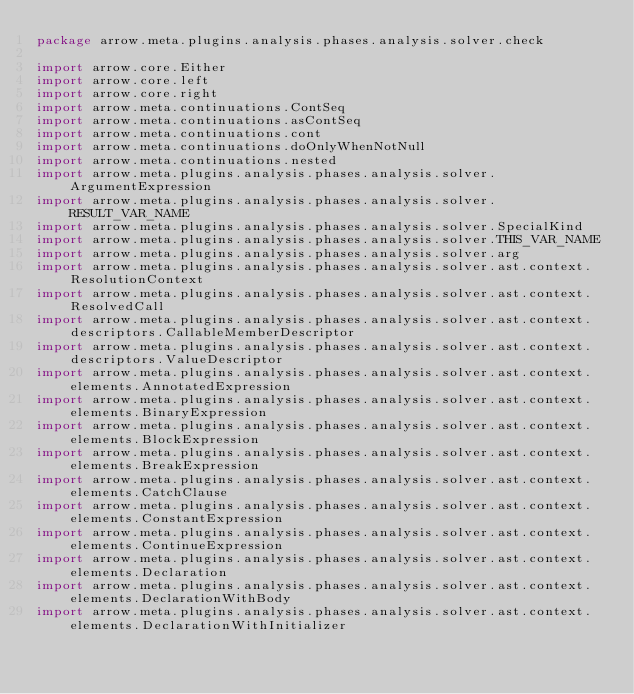Convert code to text. <code><loc_0><loc_0><loc_500><loc_500><_Kotlin_>package arrow.meta.plugins.analysis.phases.analysis.solver.check

import arrow.core.Either
import arrow.core.left
import arrow.core.right
import arrow.meta.continuations.ContSeq
import arrow.meta.continuations.asContSeq
import arrow.meta.continuations.cont
import arrow.meta.continuations.doOnlyWhenNotNull
import arrow.meta.continuations.nested
import arrow.meta.plugins.analysis.phases.analysis.solver.ArgumentExpression
import arrow.meta.plugins.analysis.phases.analysis.solver.RESULT_VAR_NAME
import arrow.meta.plugins.analysis.phases.analysis.solver.SpecialKind
import arrow.meta.plugins.analysis.phases.analysis.solver.THIS_VAR_NAME
import arrow.meta.plugins.analysis.phases.analysis.solver.arg
import arrow.meta.plugins.analysis.phases.analysis.solver.ast.context.ResolutionContext
import arrow.meta.plugins.analysis.phases.analysis.solver.ast.context.ResolvedCall
import arrow.meta.plugins.analysis.phases.analysis.solver.ast.context.descriptors.CallableMemberDescriptor
import arrow.meta.plugins.analysis.phases.analysis.solver.ast.context.descriptors.ValueDescriptor
import arrow.meta.plugins.analysis.phases.analysis.solver.ast.context.elements.AnnotatedExpression
import arrow.meta.plugins.analysis.phases.analysis.solver.ast.context.elements.BinaryExpression
import arrow.meta.plugins.analysis.phases.analysis.solver.ast.context.elements.BlockExpression
import arrow.meta.plugins.analysis.phases.analysis.solver.ast.context.elements.BreakExpression
import arrow.meta.plugins.analysis.phases.analysis.solver.ast.context.elements.CatchClause
import arrow.meta.plugins.analysis.phases.analysis.solver.ast.context.elements.ConstantExpression
import arrow.meta.plugins.analysis.phases.analysis.solver.ast.context.elements.ContinueExpression
import arrow.meta.plugins.analysis.phases.analysis.solver.ast.context.elements.Declaration
import arrow.meta.plugins.analysis.phases.analysis.solver.ast.context.elements.DeclarationWithBody
import arrow.meta.plugins.analysis.phases.analysis.solver.ast.context.elements.DeclarationWithInitializer</code> 